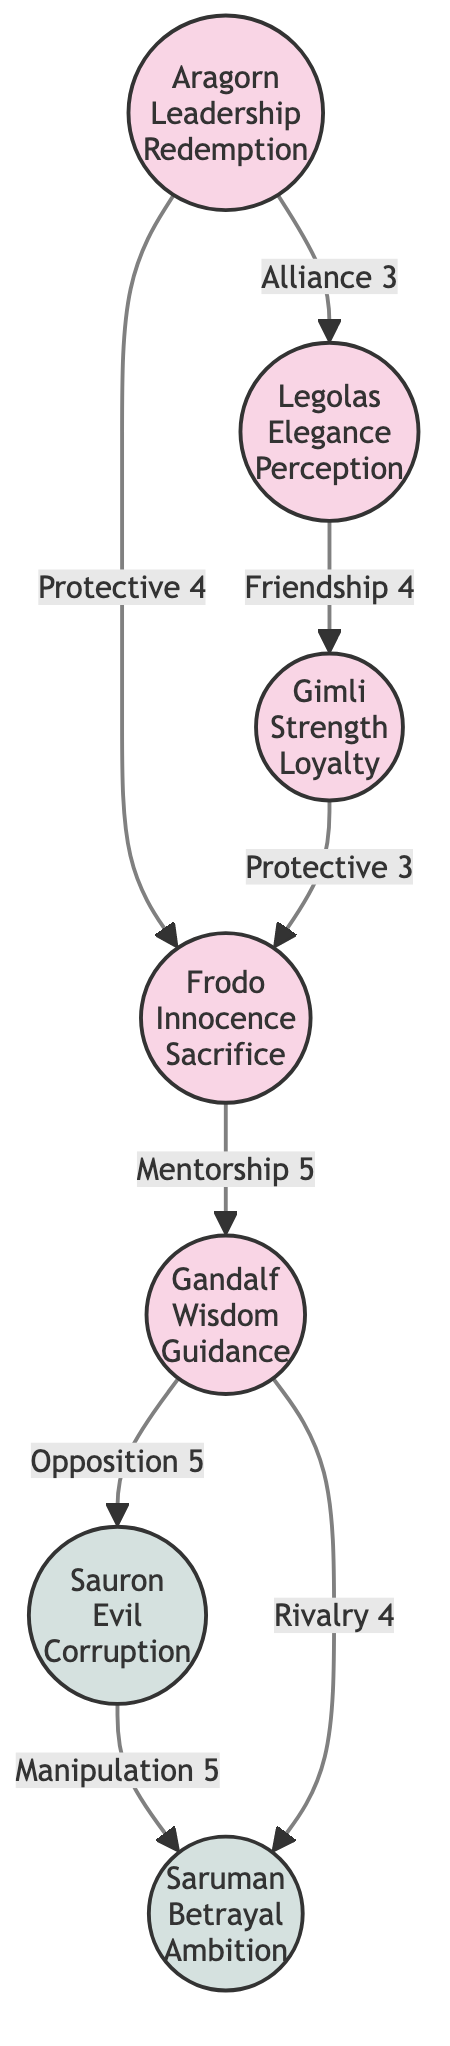What is the total number of characters in the diagram? The diagram contains seven character nodes: Aragorn, Frodo, Gandalf, Legolas, Gimli, Sauron, and Saruman. We count each unique character represented in the diagram.
Answer: 7 Which character has the attribute "Wisdom"? By inspecting the nodes, we find that the character Gandalf is labeled with the attribute "Wisdom."
Answer: Gandalf What relationship connects Aragorn and Frodo? The diagram shows an edge between Aragorn and Frodo labeled "Protective 4." This indicates the nature of their relationship.
Answer: Protective How many edges are connected to Saruman? Counting the edges, Saruman has two connections: one to Sauron, labeled "Manipulation 5," and one to Gandalf, labeled "Rivalry 4." This gives a total of two connections.
Answer: 2 Which two characters are connected by a relationship of "Friendship"? The diagram indicates a connection between Legolas and Gimli with the label "Friendship 4." This shows their interaction type and its intensity rating.
Answer: Legolas and Gimli What is the strength of the relationship between Gandalf and Sauron? Looking at the diagram, Gandalf has an edge to Sauron labeled "Opposition 5," indicating the strength of their relationship in the context of the story.
Answer: 5 Which character exhibits "Corruption"? From the diagram, it is clear that Sauron is labeled with the attribute "Corruption."
Answer: Sauron What is the nature of the relationship between Frodo and Gandalf? The edge connecting Frodo and Gandalf is labeled "Mentorship 5," indicating that Gandalf plays a mentorship role for Frodo.
Answer: Mentorship Which character is the most protective according to their relationships? Analyzing the diagram, Aragorn has two protective relationships (one with Frodo labeled "Protective 4" and another with Legolas labeled "Alliance 3"). However, since there is no direct comparison of all protective ratings, Aragorn appears to be the most protective in terms of spidering connections.
Answer: Aragorn 